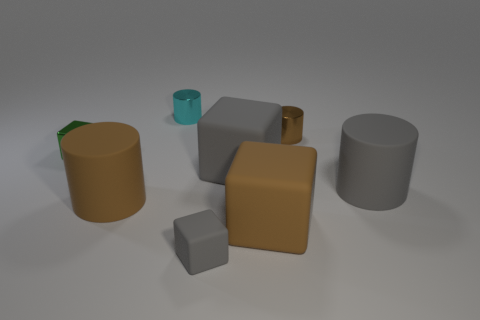There is a small cyan shiny object; are there any matte blocks behind it? no 